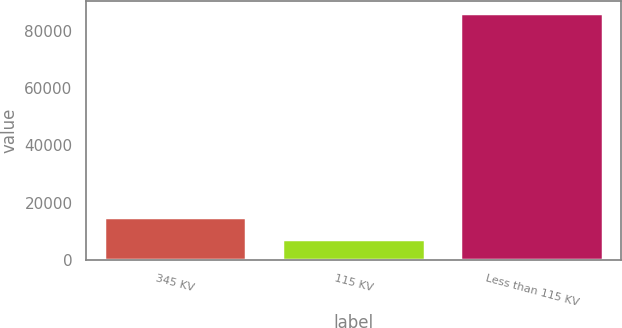Convert chart to OTSL. <chart><loc_0><loc_0><loc_500><loc_500><bar_chart><fcel>345 KV<fcel>115 KV<fcel>Less than 115 KV<nl><fcel>15253.3<fcel>7372<fcel>86185<nl></chart> 